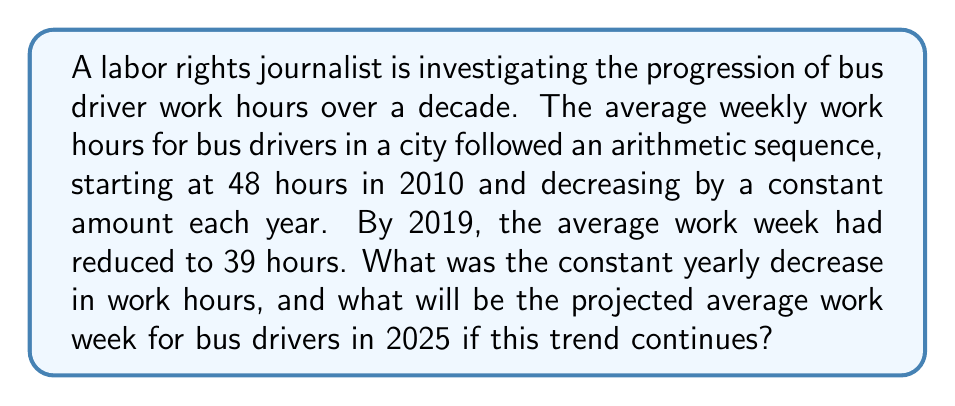Solve this math problem. Let's approach this step-by-step:

1) We're dealing with an arithmetic sequence where:
   - First term (2010): $a_1 = 48$ hours
   - Last known term (2019): $a_{10} = 39$ hours
   - We need to find the common difference $d$

2) For an arithmetic sequence, we can use the formula:
   $a_n = a_1 + (n-1)d$

3) Substituting our known values:
   $39 = 48 + (10-1)d$
   $39 = 48 + 9d$

4) Solving for $d$:
   $39 - 48 = 9d$
   $-9 = 9d$
   $d = -1$

5) So, the work hours decreased by 1 hour each year.

6) To project the average work week for 2025:
   - 2025 is 16 years from 2010
   - Using the same formula: $a_{16} = 48 + (16-1)(-1)$
   $a_{16} = 48 - 15 = 33$

Therefore, the projected average work week for bus drivers in 2025 is 33 hours.
Answer: $d = -1$, 33 hours 